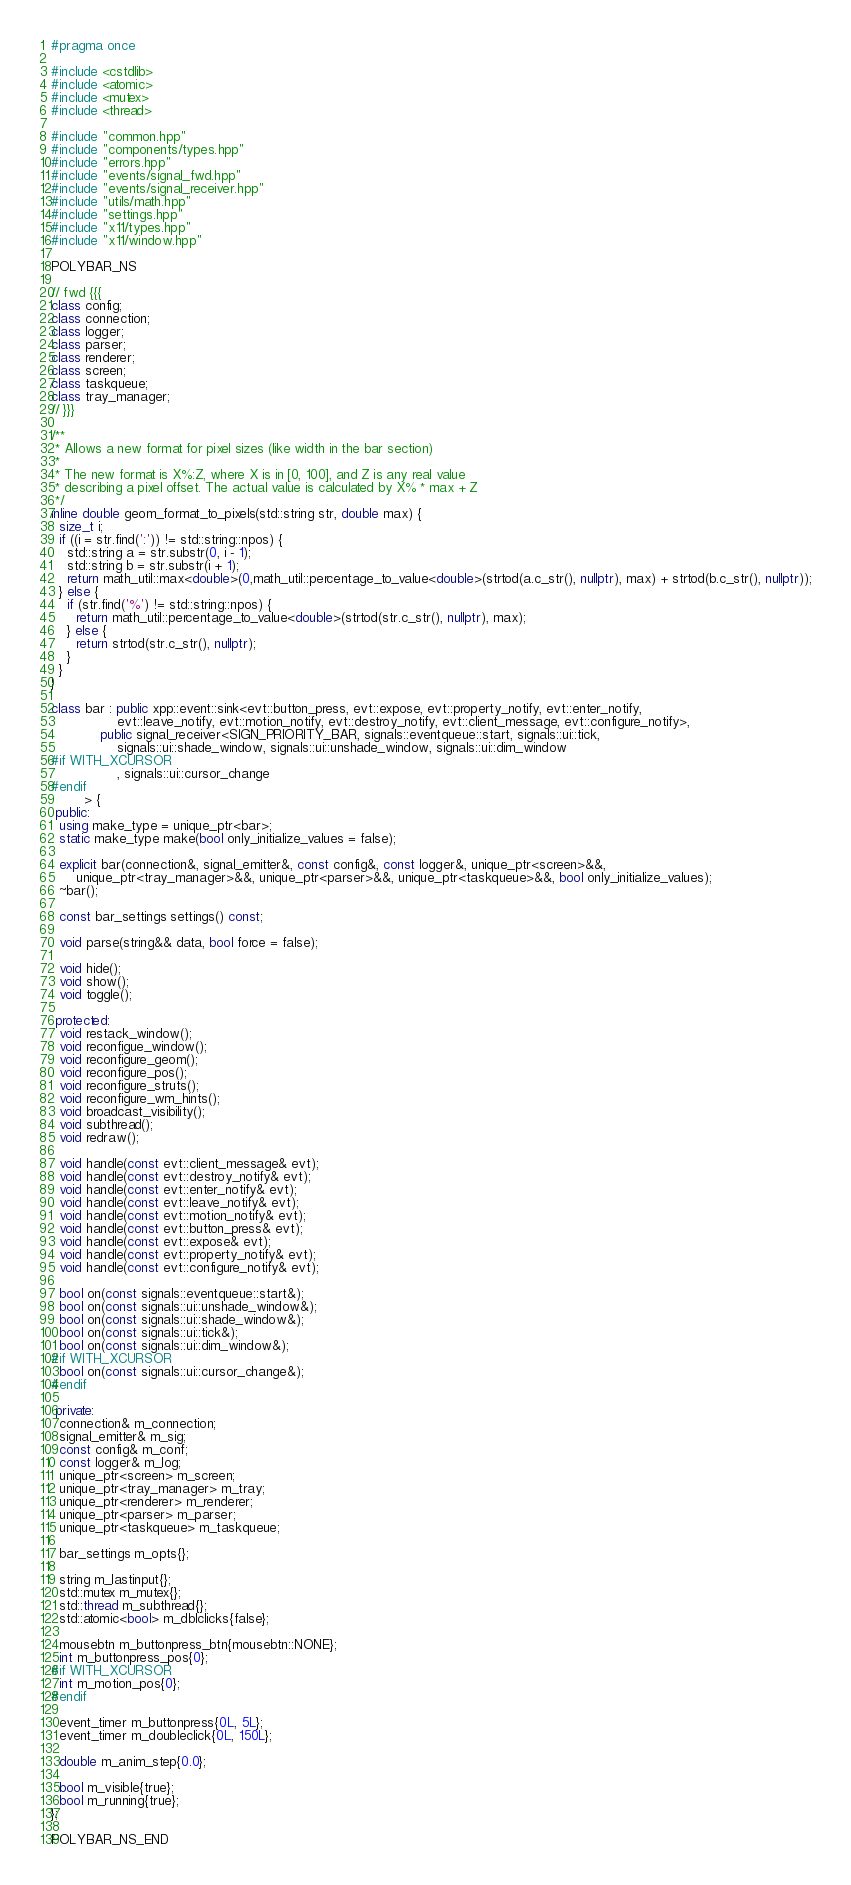<code> <loc_0><loc_0><loc_500><loc_500><_C++_>#pragma once

#include <cstdlib>
#include <atomic>
#include <mutex>
#include <thread>

#include "common.hpp"
#include "components/types.hpp"
#include "errors.hpp"
#include "events/signal_fwd.hpp"
#include "events/signal_receiver.hpp"
#include "utils/math.hpp"
#include "settings.hpp"
#include "x11/types.hpp"
#include "x11/window.hpp"

POLYBAR_NS

// fwd {{{
class config;
class connection;
class logger;
class parser;
class renderer;
class screen;
class taskqueue;
class tray_manager;
// }}}

/**
 * Allows a new format for pixel sizes (like width in the bar section)
 *
 * The new format is X%:Z, where X is in [0, 100], and Z is any real value
 * describing a pixel offset. The actual value is calculated by X% * max + Z
 */
inline double geom_format_to_pixels(std::string str, double max) {
  size_t i;
  if ((i = str.find(':')) != std::string::npos) {
    std::string a = str.substr(0, i - 1);
    std::string b = str.substr(i + 1);
    return math_util::max<double>(0,math_util::percentage_to_value<double>(strtod(a.c_str(), nullptr), max) + strtod(b.c_str(), nullptr));
  } else {
    if (str.find('%') != std::string::npos) {
      return math_util::percentage_to_value<double>(strtod(str.c_str(), nullptr), max);
    } else {
      return strtod(str.c_str(), nullptr);
    }
  }
}

class bar : public xpp::event::sink<evt::button_press, evt::expose, evt::property_notify, evt::enter_notify,
                evt::leave_notify, evt::motion_notify, evt::destroy_notify, evt::client_message, evt::configure_notify>,
            public signal_receiver<SIGN_PRIORITY_BAR, signals::eventqueue::start, signals::ui::tick,
                signals::ui::shade_window, signals::ui::unshade_window, signals::ui::dim_window
#if WITH_XCURSOR
                , signals::ui::cursor_change
#endif
		> {
 public:
  using make_type = unique_ptr<bar>;
  static make_type make(bool only_initialize_values = false);

  explicit bar(connection&, signal_emitter&, const config&, const logger&, unique_ptr<screen>&&,
      unique_ptr<tray_manager>&&, unique_ptr<parser>&&, unique_ptr<taskqueue>&&, bool only_initialize_values);
  ~bar();

  const bar_settings settings() const;

  void parse(string&& data, bool force = false);

  void hide();
  void show();
  void toggle();

 protected:
  void restack_window();
  void reconfigue_window();
  void reconfigure_geom();
  void reconfigure_pos();
  void reconfigure_struts();
  void reconfigure_wm_hints();
  void broadcast_visibility();
  void subthread();
  void redraw();

  void handle(const evt::client_message& evt);
  void handle(const evt::destroy_notify& evt);
  void handle(const evt::enter_notify& evt);
  void handle(const evt::leave_notify& evt);
  void handle(const evt::motion_notify& evt);
  void handle(const evt::button_press& evt);
  void handle(const evt::expose& evt);
  void handle(const evt::property_notify& evt);
  void handle(const evt::configure_notify& evt);

  bool on(const signals::eventqueue::start&);
  bool on(const signals::ui::unshade_window&);
  bool on(const signals::ui::shade_window&);
  bool on(const signals::ui::tick&);
  bool on(const signals::ui::dim_window&);
#if WITH_XCURSOR
  bool on(const signals::ui::cursor_change&);
#endif

 private:
  connection& m_connection;
  signal_emitter& m_sig;
  const config& m_conf;
  const logger& m_log;
  unique_ptr<screen> m_screen;
  unique_ptr<tray_manager> m_tray;
  unique_ptr<renderer> m_renderer;
  unique_ptr<parser> m_parser;
  unique_ptr<taskqueue> m_taskqueue;

  bar_settings m_opts{};

  string m_lastinput{};
  std::mutex m_mutex{};
  std::thread m_subthread{};
  std::atomic<bool> m_dblclicks{false};

  mousebtn m_buttonpress_btn{mousebtn::NONE};
  int m_buttonpress_pos{0};
#if WITH_XCURSOR
  int m_motion_pos{0};
#endif

  event_timer m_buttonpress{0L, 5L};
  event_timer m_doubleclick{0L, 150L};

  double m_anim_step{0.0};

  bool m_visible{true};
  bool m_running{true};
};

POLYBAR_NS_END
</code> 